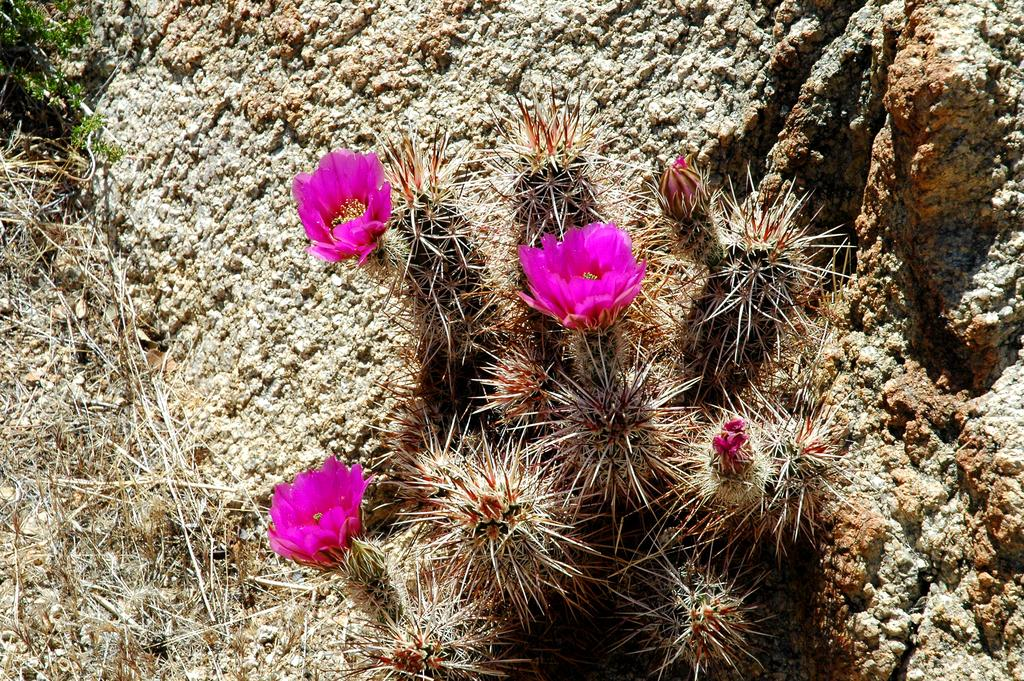What type of plants can be seen in the image? There are flowers in the image. What else can be seen in the image besides the flowers? There is grass in the image. Where are the flowers and grass located? The flowers and grass are on rocks. Who created the throne that is visible in the image? There is no throne present in the image. 